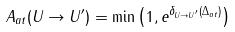<formula> <loc_0><loc_0><loc_500><loc_500>A _ { a t } ( U \rightarrow U ^ { \prime } ) = \min \left ( 1 , e ^ { \delta _ { U \rightarrow U ^ { \prime } } ( \Delta _ { a t } ) } \right )</formula> 